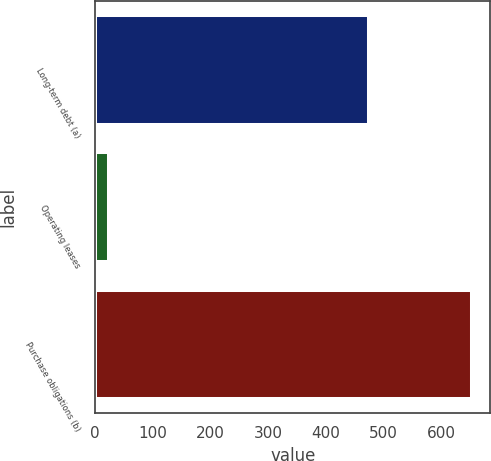Convert chart. <chart><loc_0><loc_0><loc_500><loc_500><bar_chart><fcel>Long-term debt (a)<fcel>Operating leases<fcel>Purchase obligations (b)<nl><fcel>475<fcel>24<fcel>652<nl></chart> 